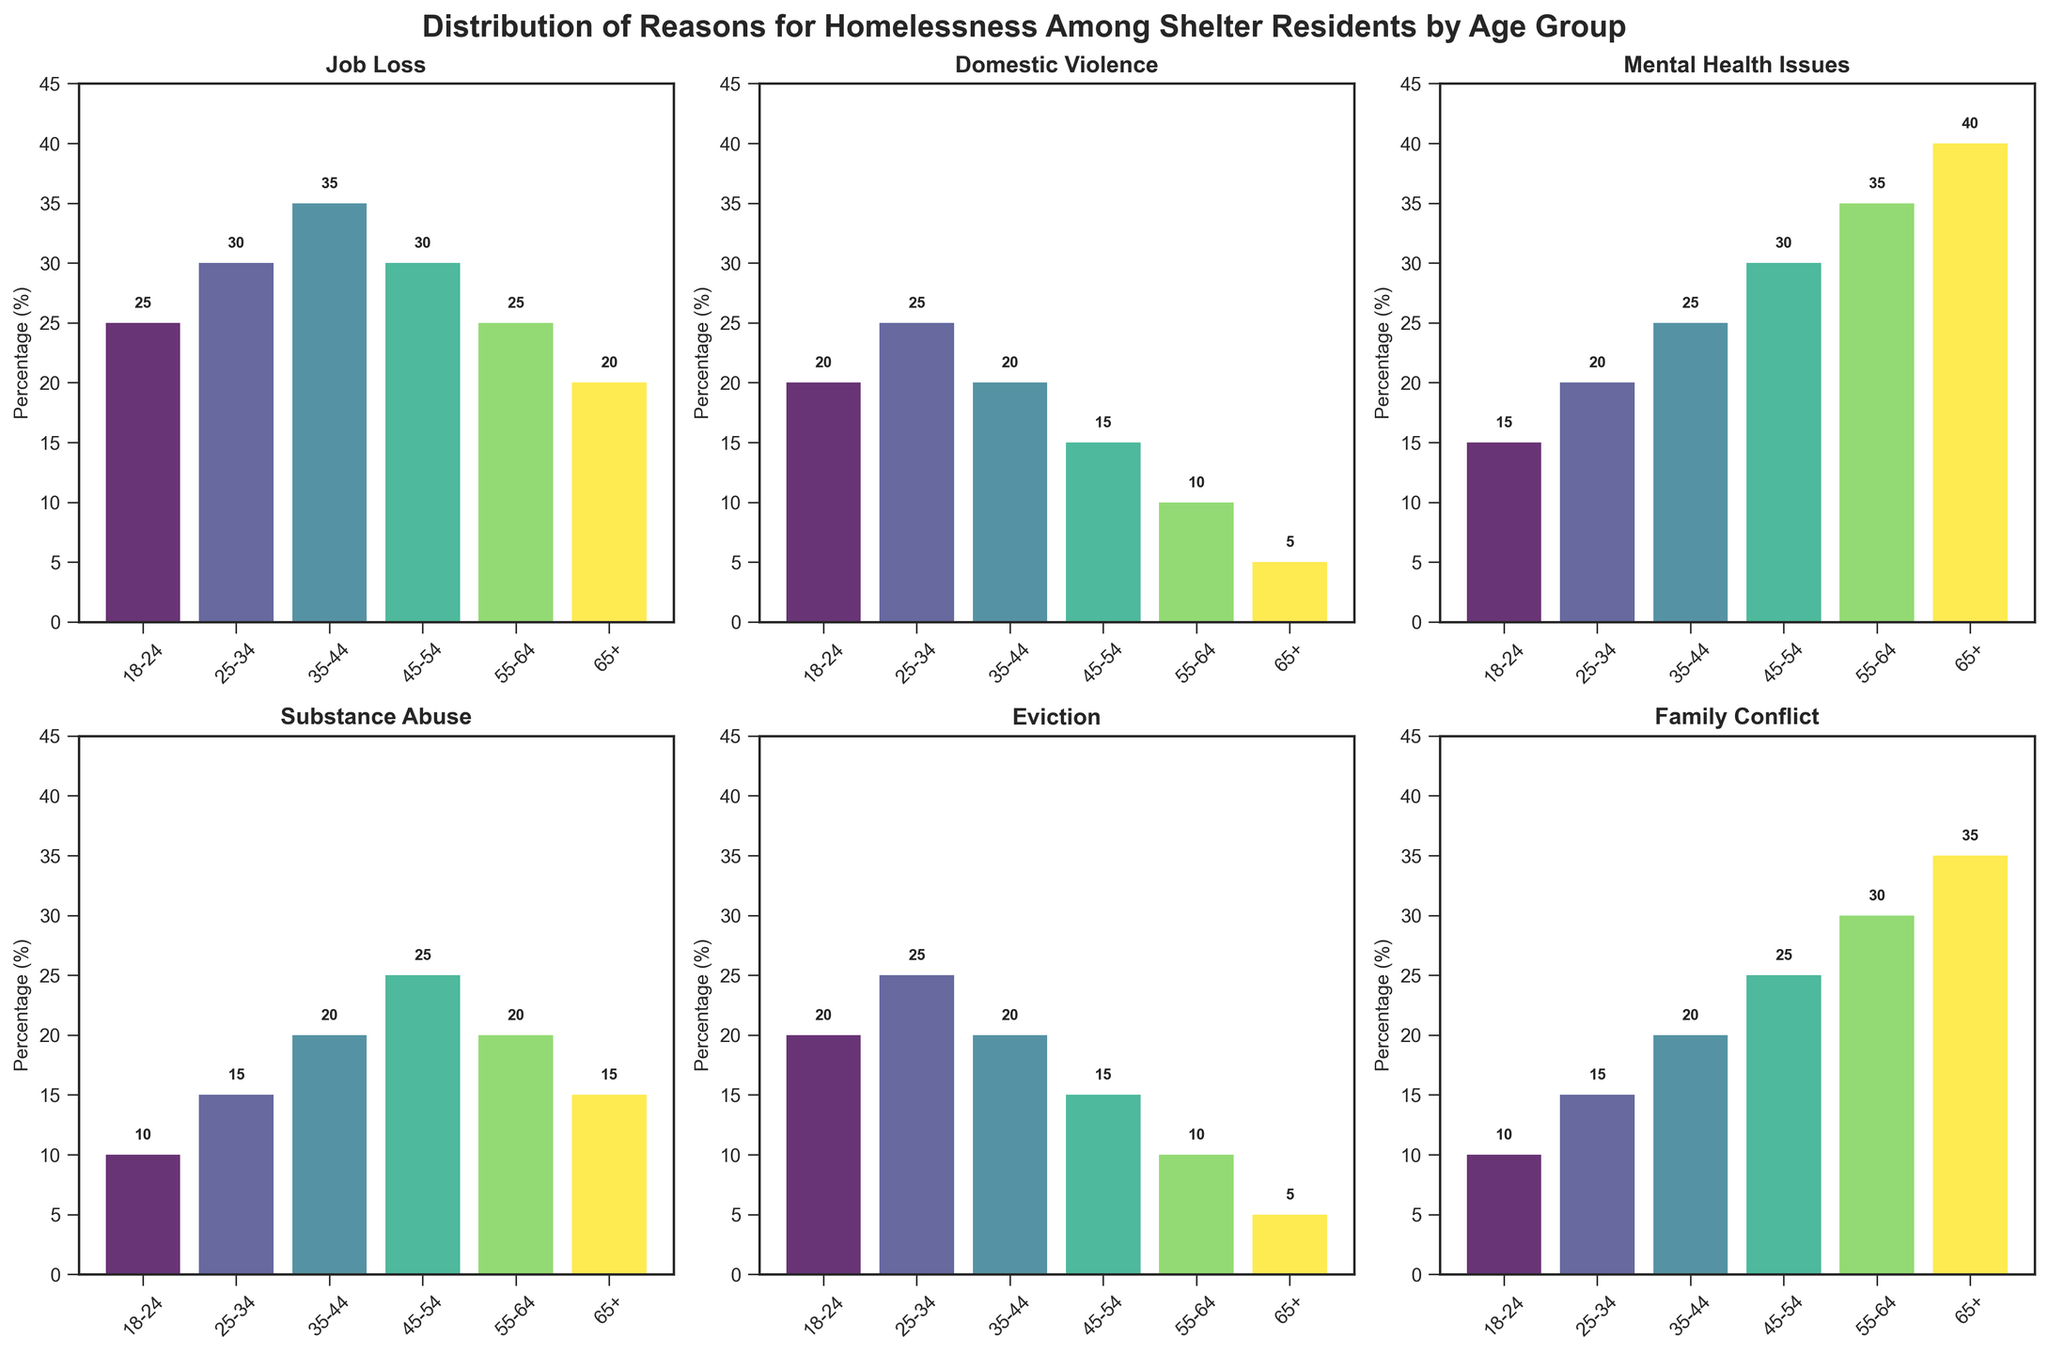What is the title of the figure? The title of the figure is displayed at the top of the plot. It reads 'Distribution of Reasons for Homelessness Among Shelter Residents by Age Group'.
Answer: Distribution of Reasons for Homelessness Among Shelter Residents by Age Group Which age group has the highest percentage of eviction as a reason for homelessness? Looking at the subplot for eviction, it shows that the age group 25-34 has the highest visible bar corresponding to an eviction percentage of 25%.
Answer: 25-34 In the age group 45-54, which reason for homelessness has the highest percentage? To find the highest reason for homelessness in the 45-54 age group, we compare the heights of the bars in the subplot: Job Loss (30), Domestic Violence (15), Mental Health Issues (30), Substance Abuse (25), Eviction (15), Family Conflict (25). The highest are Job Loss and Mental Health Issues, both with 30%.
Answer: Job Loss and Mental Health Issues Which reason for homelessness has the highest percentage for age 65+? On the subplot for the 65+ age group, Mental Health Issues bar reaches the highest percentage, 40%.
Answer: Mental Health Issues Compare the percentage of Substance Abuse and Family Conflict for the age group 18-24. Which is higher and by how much? In the subplot for Substance Abuse and Family Conflict, the age group 18-24 shows Substance Abuse at 10% and Family Conflict at 10%. The difference between these values is 0%.
Answer: Both are equal What is the overall trend in the Mental Health Issues across different age groups? Looking at the subplot for Mental Health Issues: Age groups 18-24 (15), 25-34 (20), 35-44 (25), 45-54 (30), 55-64 (35), 65+ (40), we see that the percentage consistently increases with age.
Answer: Increases with age For the age group 55-64, what’s the difference between the percentages of Job Loss and Domestic Violence? For the age group 55-64, in the subplots: Job Loss (25) and Domestic Violence (10). The difference, calculated as 25 - 10, is 15%.
Answer: 15% Which reason for homelessness shows the greatest variability across age groups? By visually inspecting the variations in bar heights across subplots: 'Mental Health Issues' shows a low of 15% in the 18-24 group and a high of 40% in the 65+ group, showing significant variability.
Answer: Mental Health Issues Which age group has the lowest percentage of Domestic Violence as a reason for homelessness? From the subplot for Domestic Violence, it is clear that the 65+ age group has the lowest percentage, which is 5%.
Answer: 65+ What is the average percentage of Eviction for all age groups? The average percentage is calculated by summing the percentages for all age groups and dividing by the number of groups: (20 + 25 + 20 + 15 + 10 + 5) / 6 = 15.83%.
Answer: 15.83% 